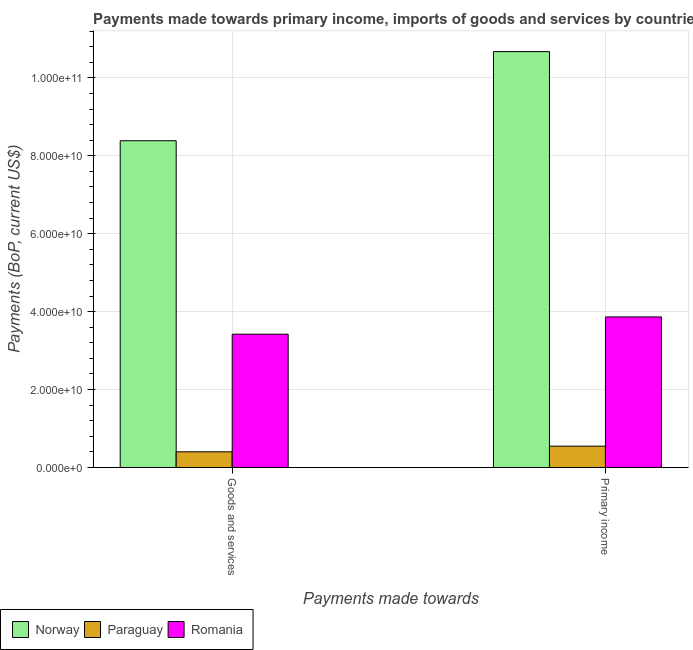Are the number of bars per tick equal to the number of legend labels?
Keep it short and to the point. Yes. How many bars are there on the 1st tick from the right?
Give a very brief answer. 3. What is the label of the 2nd group of bars from the left?
Offer a very short reply. Primary income. What is the payments made towards goods and services in Romania?
Give a very brief answer. 3.42e+1. Across all countries, what is the maximum payments made towards goods and services?
Give a very brief answer. 8.39e+1. Across all countries, what is the minimum payments made towards goods and services?
Provide a succinct answer. 4.03e+09. In which country was the payments made towards primary income minimum?
Keep it short and to the point. Paraguay. What is the total payments made towards primary income in the graph?
Provide a short and direct response. 1.51e+11. What is the difference between the payments made towards primary income in Romania and that in Norway?
Offer a terse response. -6.81e+1. What is the difference between the payments made towards primary income in Romania and the payments made towards goods and services in Paraguay?
Give a very brief answer. 3.46e+1. What is the average payments made towards goods and services per country?
Give a very brief answer. 4.07e+1. What is the difference between the payments made towards goods and services and payments made towards primary income in Norway?
Your response must be concise. -2.29e+1. In how many countries, is the payments made towards goods and services greater than 40000000000 US$?
Your response must be concise. 1. What is the ratio of the payments made towards goods and services in Paraguay to that in Romania?
Offer a terse response. 0.12. What does the 3rd bar from the left in Primary income represents?
Your response must be concise. Romania. What does the 1st bar from the right in Primary income represents?
Your answer should be compact. Romania. Are all the bars in the graph horizontal?
Make the answer very short. No. How many countries are there in the graph?
Provide a succinct answer. 3. What is the difference between two consecutive major ticks on the Y-axis?
Keep it short and to the point. 2.00e+1. Are the values on the major ticks of Y-axis written in scientific E-notation?
Your answer should be compact. Yes. Does the graph contain any zero values?
Your answer should be very brief. No. Does the graph contain grids?
Provide a short and direct response. Yes. Where does the legend appear in the graph?
Your answer should be very brief. Bottom left. How many legend labels are there?
Provide a short and direct response. 3. What is the title of the graph?
Keep it short and to the point. Payments made towards primary income, imports of goods and services by countries. What is the label or title of the X-axis?
Keep it short and to the point. Payments made towards. What is the label or title of the Y-axis?
Keep it short and to the point. Payments (BoP, current US$). What is the Payments (BoP, current US$) in Norway in Goods and services?
Give a very brief answer. 8.39e+1. What is the Payments (BoP, current US$) in Paraguay in Goods and services?
Your answer should be very brief. 4.03e+09. What is the Payments (BoP, current US$) in Romania in Goods and services?
Give a very brief answer. 3.42e+1. What is the Payments (BoP, current US$) in Norway in Primary income?
Your answer should be very brief. 1.07e+11. What is the Payments (BoP, current US$) in Paraguay in Primary income?
Your answer should be very brief. 5.47e+09. What is the Payments (BoP, current US$) of Romania in Primary income?
Give a very brief answer. 3.86e+1. Across all Payments made towards, what is the maximum Payments (BoP, current US$) in Norway?
Make the answer very short. 1.07e+11. Across all Payments made towards, what is the maximum Payments (BoP, current US$) of Paraguay?
Offer a terse response. 5.47e+09. Across all Payments made towards, what is the maximum Payments (BoP, current US$) in Romania?
Your answer should be very brief. 3.86e+1. Across all Payments made towards, what is the minimum Payments (BoP, current US$) of Norway?
Provide a short and direct response. 8.39e+1. Across all Payments made towards, what is the minimum Payments (BoP, current US$) of Paraguay?
Offer a terse response. 4.03e+09. Across all Payments made towards, what is the minimum Payments (BoP, current US$) in Romania?
Keep it short and to the point. 3.42e+1. What is the total Payments (BoP, current US$) of Norway in the graph?
Keep it short and to the point. 1.91e+11. What is the total Payments (BoP, current US$) in Paraguay in the graph?
Ensure brevity in your answer.  9.50e+09. What is the total Payments (BoP, current US$) in Romania in the graph?
Your answer should be compact. 7.29e+1. What is the difference between the Payments (BoP, current US$) in Norway in Goods and services and that in Primary income?
Your answer should be compact. -2.29e+1. What is the difference between the Payments (BoP, current US$) of Paraguay in Goods and services and that in Primary income?
Your response must be concise. -1.45e+09. What is the difference between the Payments (BoP, current US$) in Romania in Goods and services and that in Primary income?
Your answer should be very brief. -4.43e+09. What is the difference between the Payments (BoP, current US$) of Norway in Goods and services and the Payments (BoP, current US$) of Paraguay in Primary income?
Provide a short and direct response. 7.84e+1. What is the difference between the Payments (BoP, current US$) of Norway in Goods and services and the Payments (BoP, current US$) of Romania in Primary income?
Provide a short and direct response. 4.52e+1. What is the difference between the Payments (BoP, current US$) of Paraguay in Goods and services and the Payments (BoP, current US$) of Romania in Primary income?
Provide a short and direct response. -3.46e+1. What is the average Payments (BoP, current US$) in Norway per Payments made towards?
Provide a succinct answer. 9.53e+1. What is the average Payments (BoP, current US$) of Paraguay per Payments made towards?
Make the answer very short. 4.75e+09. What is the average Payments (BoP, current US$) in Romania per Payments made towards?
Provide a short and direct response. 3.64e+1. What is the difference between the Payments (BoP, current US$) of Norway and Payments (BoP, current US$) of Paraguay in Goods and services?
Your response must be concise. 7.98e+1. What is the difference between the Payments (BoP, current US$) in Norway and Payments (BoP, current US$) in Romania in Goods and services?
Keep it short and to the point. 4.97e+1. What is the difference between the Payments (BoP, current US$) in Paraguay and Payments (BoP, current US$) in Romania in Goods and services?
Your response must be concise. -3.02e+1. What is the difference between the Payments (BoP, current US$) in Norway and Payments (BoP, current US$) in Paraguay in Primary income?
Provide a short and direct response. 1.01e+11. What is the difference between the Payments (BoP, current US$) in Norway and Payments (BoP, current US$) in Romania in Primary income?
Your answer should be very brief. 6.81e+1. What is the difference between the Payments (BoP, current US$) of Paraguay and Payments (BoP, current US$) of Romania in Primary income?
Provide a short and direct response. -3.32e+1. What is the ratio of the Payments (BoP, current US$) of Norway in Goods and services to that in Primary income?
Offer a terse response. 0.79. What is the ratio of the Payments (BoP, current US$) in Paraguay in Goods and services to that in Primary income?
Offer a very short reply. 0.74. What is the ratio of the Payments (BoP, current US$) in Romania in Goods and services to that in Primary income?
Keep it short and to the point. 0.89. What is the difference between the highest and the second highest Payments (BoP, current US$) in Norway?
Offer a very short reply. 2.29e+1. What is the difference between the highest and the second highest Payments (BoP, current US$) of Paraguay?
Make the answer very short. 1.45e+09. What is the difference between the highest and the second highest Payments (BoP, current US$) in Romania?
Your answer should be very brief. 4.43e+09. What is the difference between the highest and the lowest Payments (BoP, current US$) of Norway?
Provide a succinct answer. 2.29e+1. What is the difference between the highest and the lowest Payments (BoP, current US$) in Paraguay?
Provide a succinct answer. 1.45e+09. What is the difference between the highest and the lowest Payments (BoP, current US$) in Romania?
Your answer should be compact. 4.43e+09. 